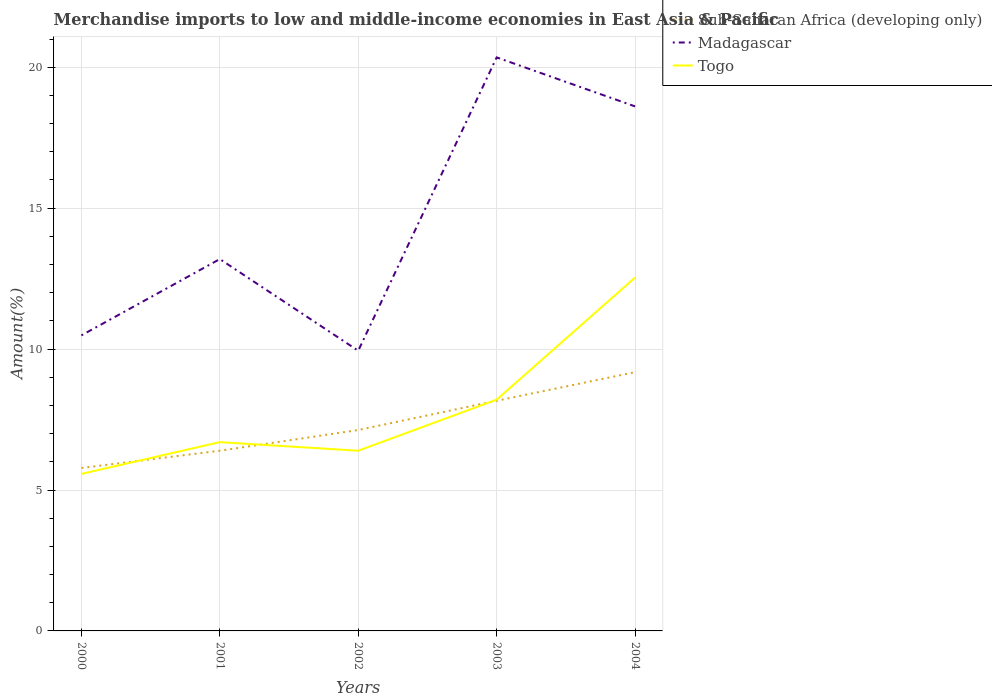Across all years, what is the maximum percentage of amount earned from merchandise imports in Sub-Saharan Africa (developing only)?
Keep it short and to the point. 5.78. What is the total percentage of amount earned from merchandise imports in Sub-Saharan Africa (developing only) in the graph?
Provide a succinct answer. -1.01. What is the difference between the highest and the second highest percentage of amount earned from merchandise imports in Madagascar?
Offer a terse response. 10.41. Is the percentage of amount earned from merchandise imports in Sub-Saharan Africa (developing only) strictly greater than the percentage of amount earned from merchandise imports in Togo over the years?
Ensure brevity in your answer.  No. How many years are there in the graph?
Keep it short and to the point. 5. Does the graph contain grids?
Ensure brevity in your answer.  Yes. How many legend labels are there?
Provide a short and direct response. 3. How are the legend labels stacked?
Your answer should be very brief. Vertical. What is the title of the graph?
Give a very brief answer. Merchandise imports to low and middle-income economies in East Asia & Pacific. Does "St. Martin (French part)" appear as one of the legend labels in the graph?
Your answer should be very brief. No. What is the label or title of the X-axis?
Provide a succinct answer. Years. What is the label or title of the Y-axis?
Ensure brevity in your answer.  Amount(%). What is the Amount(%) in Sub-Saharan Africa (developing only) in 2000?
Offer a very short reply. 5.78. What is the Amount(%) in Madagascar in 2000?
Make the answer very short. 10.49. What is the Amount(%) in Togo in 2000?
Provide a short and direct response. 5.57. What is the Amount(%) of Sub-Saharan Africa (developing only) in 2001?
Give a very brief answer. 6.39. What is the Amount(%) in Madagascar in 2001?
Ensure brevity in your answer.  13.19. What is the Amount(%) of Togo in 2001?
Make the answer very short. 6.7. What is the Amount(%) in Sub-Saharan Africa (developing only) in 2002?
Your answer should be very brief. 7.13. What is the Amount(%) in Madagascar in 2002?
Provide a succinct answer. 9.94. What is the Amount(%) of Togo in 2002?
Offer a terse response. 6.39. What is the Amount(%) in Sub-Saharan Africa (developing only) in 2003?
Provide a succinct answer. 8.17. What is the Amount(%) of Madagascar in 2003?
Ensure brevity in your answer.  20.35. What is the Amount(%) of Togo in 2003?
Offer a very short reply. 8.21. What is the Amount(%) of Sub-Saharan Africa (developing only) in 2004?
Offer a very short reply. 9.18. What is the Amount(%) of Madagascar in 2004?
Offer a terse response. 18.61. What is the Amount(%) of Togo in 2004?
Provide a short and direct response. 12.54. Across all years, what is the maximum Amount(%) in Sub-Saharan Africa (developing only)?
Your response must be concise. 9.18. Across all years, what is the maximum Amount(%) of Madagascar?
Ensure brevity in your answer.  20.35. Across all years, what is the maximum Amount(%) in Togo?
Ensure brevity in your answer.  12.54. Across all years, what is the minimum Amount(%) in Sub-Saharan Africa (developing only)?
Your answer should be compact. 5.78. Across all years, what is the minimum Amount(%) of Madagascar?
Give a very brief answer. 9.94. Across all years, what is the minimum Amount(%) in Togo?
Provide a short and direct response. 5.57. What is the total Amount(%) of Sub-Saharan Africa (developing only) in the graph?
Your answer should be very brief. 36.65. What is the total Amount(%) in Madagascar in the graph?
Offer a terse response. 72.58. What is the total Amount(%) in Togo in the graph?
Offer a terse response. 39.41. What is the difference between the Amount(%) of Sub-Saharan Africa (developing only) in 2000 and that in 2001?
Provide a short and direct response. -0.61. What is the difference between the Amount(%) in Madagascar in 2000 and that in 2001?
Your answer should be compact. -2.71. What is the difference between the Amount(%) in Togo in 2000 and that in 2001?
Your response must be concise. -1.13. What is the difference between the Amount(%) in Sub-Saharan Africa (developing only) in 2000 and that in 2002?
Ensure brevity in your answer.  -1.35. What is the difference between the Amount(%) of Madagascar in 2000 and that in 2002?
Your answer should be very brief. 0.54. What is the difference between the Amount(%) of Togo in 2000 and that in 2002?
Provide a succinct answer. -0.82. What is the difference between the Amount(%) of Sub-Saharan Africa (developing only) in 2000 and that in 2003?
Provide a short and direct response. -2.39. What is the difference between the Amount(%) in Madagascar in 2000 and that in 2003?
Provide a succinct answer. -9.86. What is the difference between the Amount(%) in Togo in 2000 and that in 2003?
Offer a very short reply. -2.64. What is the difference between the Amount(%) in Sub-Saharan Africa (developing only) in 2000 and that in 2004?
Your answer should be compact. -3.4. What is the difference between the Amount(%) in Madagascar in 2000 and that in 2004?
Your answer should be very brief. -8.12. What is the difference between the Amount(%) in Togo in 2000 and that in 2004?
Offer a very short reply. -6.97. What is the difference between the Amount(%) in Sub-Saharan Africa (developing only) in 2001 and that in 2002?
Offer a terse response. -0.74. What is the difference between the Amount(%) of Madagascar in 2001 and that in 2002?
Give a very brief answer. 3.25. What is the difference between the Amount(%) of Togo in 2001 and that in 2002?
Your answer should be compact. 0.3. What is the difference between the Amount(%) of Sub-Saharan Africa (developing only) in 2001 and that in 2003?
Provide a short and direct response. -1.77. What is the difference between the Amount(%) of Madagascar in 2001 and that in 2003?
Make the answer very short. -7.16. What is the difference between the Amount(%) in Togo in 2001 and that in 2003?
Offer a very short reply. -1.51. What is the difference between the Amount(%) in Sub-Saharan Africa (developing only) in 2001 and that in 2004?
Your answer should be very brief. -2.79. What is the difference between the Amount(%) of Madagascar in 2001 and that in 2004?
Give a very brief answer. -5.42. What is the difference between the Amount(%) in Togo in 2001 and that in 2004?
Your response must be concise. -5.84. What is the difference between the Amount(%) in Sub-Saharan Africa (developing only) in 2002 and that in 2003?
Your answer should be compact. -1.04. What is the difference between the Amount(%) in Madagascar in 2002 and that in 2003?
Give a very brief answer. -10.41. What is the difference between the Amount(%) in Togo in 2002 and that in 2003?
Keep it short and to the point. -1.81. What is the difference between the Amount(%) in Sub-Saharan Africa (developing only) in 2002 and that in 2004?
Make the answer very short. -2.05. What is the difference between the Amount(%) of Madagascar in 2002 and that in 2004?
Offer a terse response. -8.67. What is the difference between the Amount(%) in Togo in 2002 and that in 2004?
Keep it short and to the point. -6.15. What is the difference between the Amount(%) in Sub-Saharan Africa (developing only) in 2003 and that in 2004?
Provide a succinct answer. -1.01. What is the difference between the Amount(%) of Madagascar in 2003 and that in 2004?
Your response must be concise. 1.74. What is the difference between the Amount(%) of Togo in 2003 and that in 2004?
Keep it short and to the point. -4.33. What is the difference between the Amount(%) of Sub-Saharan Africa (developing only) in 2000 and the Amount(%) of Madagascar in 2001?
Provide a short and direct response. -7.41. What is the difference between the Amount(%) of Sub-Saharan Africa (developing only) in 2000 and the Amount(%) of Togo in 2001?
Provide a succinct answer. -0.92. What is the difference between the Amount(%) of Madagascar in 2000 and the Amount(%) of Togo in 2001?
Your answer should be compact. 3.79. What is the difference between the Amount(%) of Sub-Saharan Africa (developing only) in 2000 and the Amount(%) of Madagascar in 2002?
Keep it short and to the point. -4.16. What is the difference between the Amount(%) in Sub-Saharan Africa (developing only) in 2000 and the Amount(%) in Togo in 2002?
Ensure brevity in your answer.  -0.61. What is the difference between the Amount(%) of Madagascar in 2000 and the Amount(%) of Togo in 2002?
Offer a terse response. 4.09. What is the difference between the Amount(%) of Sub-Saharan Africa (developing only) in 2000 and the Amount(%) of Madagascar in 2003?
Offer a terse response. -14.57. What is the difference between the Amount(%) of Sub-Saharan Africa (developing only) in 2000 and the Amount(%) of Togo in 2003?
Keep it short and to the point. -2.42. What is the difference between the Amount(%) in Madagascar in 2000 and the Amount(%) in Togo in 2003?
Ensure brevity in your answer.  2.28. What is the difference between the Amount(%) of Sub-Saharan Africa (developing only) in 2000 and the Amount(%) of Madagascar in 2004?
Provide a short and direct response. -12.83. What is the difference between the Amount(%) in Sub-Saharan Africa (developing only) in 2000 and the Amount(%) in Togo in 2004?
Your answer should be very brief. -6.76. What is the difference between the Amount(%) in Madagascar in 2000 and the Amount(%) in Togo in 2004?
Make the answer very short. -2.05. What is the difference between the Amount(%) of Sub-Saharan Africa (developing only) in 2001 and the Amount(%) of Madagascar in 2002?
Make the answer very short. -3.55. What is the difference between the Amount(%) of Madagascar in 2001 and the Amount(%) of Togo in 2002?
Ensure brevity in your answer.  6.8. What is the difference between the Amount(%) of Sub-Saharan Africa (developing only) in 2001 and the Amount(%) of Madagascar in 2003?
Offer a very short reply. -13.96. What is the difference between the Amount(%) in Sub-Saharan Africa (developing only) in 2001 and the Amount(%) in Togo in 2003?
Offer a terse response. -1.81. What is the difference between the Amount(%) in Madagascar in 2001 and the Amount(%) in Togo in 2003?
Your response must be concise. 4.99. What is the difference between the Amount(%) in Sub-Saharan Africa (developing only) in 2001 and the Amount(%) in Madagascar in 2004?
Provide a succinct answer. -12.22. What is the difference between the Amount(%) in Sub-Saharan Africa (developing only) in 2001 and the Amount(%) in Togo in 2004?
Make the answer very short. -6.15. What is the difference between the Amount(%) of Madagascar in 2001 and the Amount(%) of Togo in 2004?
Offer a very short reply. 0.65. What is the difference between the Amount(%) of Sub-Saharan Africa (developing only) in 2002 and the Amount(%) of Madagascar in 2003?
Offer a very short reply. -13.22. What is the difference between the Amount(%) of Sub-Saharan Africa (developing only) in 2002 and the Amount(%) of Togo in 2003?
Give a very brief answer. -1.08. What is the difference between the Amount(%) of Madagascar in 2002 and the Amount(%) of Togo in 2003?
Provide a succinct answer. 1.74. What is the difference between the Amount(%) of Sub-Saharan Africa (developing only) in 2002 and the Amount(%) of Madagascar in 2004?
Offer a terse response. -11.48. What is the difference between the Amount(%) in Sub-Saharan Africa (developing only) in 2002 and the Amount(%) in Togo in 2004?
Provide a succinct answer. -5.41. What is the difference between the Amount(%) in Madagascar in 2002 and the Amount(%) in Togo in 2004?
Make the answer very short. -2.6. What is the difference between the Amount(%) of Sub-Saharan Africa (developing only) in 2003 and the Amount(%) of Madagascar in 2004?
Your answer should be very brief. -10.44. What is the difference between the Amount(%) in Sub-Saharan Africa (developing only) in 2003 and the Amount(%) in Togo in 2004?
Make the answer very short. -4.37. What is the difference between the Amount(%) of Madagascar in 2003 and the Amount(%) of Togo in 2004?
Offer a very short reply. 7.81. What is the average Amount(%) in Sub-Saharan Africa (developing only) per year?
Ensure brevity in your answer.  7.33. What is the average Amount(%) of Madagascar per year?
Give a very brief answer. 14.52. What is the average Amount(%) of Togo per year?
Your answer should be compact. 7.88. In the year 2000, what is the difference between the Amount(%) of Sub-Saharan Africa (developing only) and Amount(%) of Madagascar?
Keep it short and to the point. -4.71. In the year 2000, what is the difference between the Amount(%) of Sub-Saharan Africa (developing only) and Amount(%) of Togo?
Provide a succinct answer. 0.21. In the year 2000, what is the difference between the Amount(%) in Madagascar and Amount(%) in Togo?
Provide a short and direct response. 4.92. In the year 2001, what is the difference between the Amount(%) of Sub-Saharan Africa (developing only) and Amount(%) of Madagascar?
Your answer should be very brief. -6.8. In the year 2001, what is the difference between the Amount(%) in Sub-Saharan Africa (developing only) and Amount(%) in Togo?
Your answer should be compact. -0.3. In the year 2001, what is the difference between the Amount(%) in Madagascar and Amount(%) in Togo?
Your answer should be very brief. 6.5. In the year 2002, what is the difference between the Amount(%) in Sub-Saharan Africa (developing only) and Amount(%) in Madagascar?
Offer a very short reply. -2.81. In the year 2002, what is the difference between the Amount(%) of Sub-Saharan Africa (developing only) and Amount(%) of Togo?
Your answer should be compact. 0.74. In the year 2002, what is the difference between the Amount(%) in Madagascar and Amount(%) in Togo?
Keep it short and to the point. 3.55. In the year 2003, what is the difference between the Amount(%) in Sub-Saharan Africa (developing only) and Amount(%) in Madagascar?
Your answer should be very brief. -12.18. In the year 2003, what is the difference between the Amount(%) in Sub-Saharan Africa (developing only) and Amount(%) in Togo?
Keep it short and to the point. -0.04. In the year 2003, what is the difference between the Amount(%) in Madagascar and Amount(%) in Togo?
Provide a short and direct response. 12.14. In the year 2004, what is the difference between the Amount(%) in Sub-Saharan Africa (developing only) and Amount(%) in Madagascar?
Make the answer very short. -9.43. In the year 2004, what is the difference between the Amount(%) of Sub-Saharan Africa (developing only) and Amount(%) of Togo?
Your answer should be very brief. -3.36. In the year 2004, what is the difference between the Amount(%) in Madagascar and Amount(%) in Togo?
Give a very brief answer. 6.07. What is the ratio of the Amount(%) of Sub-Saharan Africa (developing only) in 2000 to that in 2001?
Ensure brevity in your answer.  0.9. What is the ratio of the Amount(%) in Madagascar in 2000 to that in 2001?
Give a very brief answer. 0.79. What is the ratio of the Amount(%) of Togo in 2000 to that in 2001?
Offer a very short reply. 0.83. What is the ratio of the Amount(%) in Sub-Saharan Africa (developing only) in 2000 to that in 2002?
Give a very brief answer. 0.81. What is the ratio of the Amount(%) in Madagascar in 2000 to that in 2002?
Offer a terse response. 1.05. What is the ratio of the Amount(%) of Togo in 2000 to that in 2002?
Ensure brevity in your answer.  0.87. What is the ratio of the Amount(%) in Sub-Saharan Africa (developing only) in 2000 to that in 2003?
Offer a terse response. 0.71. What is the ratio of the Amount(%) of Madagascar in 2000 to that in 2003?
Provide a succinct answer. 0.52. What is the ratio of the Amount(%) in Togo in 2000 to that in 2003?
Give a very brief answer. 0.68. What is the ratio of the Amount(%) of Sub-Saharan Africa (developing only) in 2000 to that in 2004?
Give a very brief answer. 0.63. What is the ratio of the Amount(%) of Madagascar in 2000 to that in 2004?
Your answer should be compact. 0.56. What is the ratio of the Amount(%) in Togo in 2000 to that in 2004?
Provide a short and direct response. 0.44. What is the ratio of the Amount(%) of Sub-Saharan Africa (developing only) in 2001 to that in 2002?
Keep it short and to the point. 0.9. What is the ratio of the Amount(%) of Madagascar in 2001 to that in 2002?
Provide a succinct answer. 1.33. What is the ratio of the Amount(%) of Togo in 2001 to that in 2002?
Your response must be concise. 1.05. What is the ratio of the Amount(%) in Sub-Saharan Africa (developing only) in 2001 to that in 2003?
Ensure brevity in your answer.  0.78. What is the ratio of the Amount(%) of Madagascar in 2001 to that in 2003?
Make the answer very short. 0.65. What is the ratio of the Amount(%) in Togo in 2001 to that in 2003?
Offer a terse response. 0.82. What is the ratio of the Amount(%) of Sub-Saharan Africa (developing only) in 2001 to that in 2004?
Ensure brevity in your answer.  0.7. What is the ratio of the Amount(%) in Madagascar in 2001 to that in 2004?
Provide a succinct answer. 0.71. What is the ratio of the Amount(%) of Togo in 2001 to that in 2004?
Provide a succinct answer. 0.53. What is the ratio of the Amount(%) of Sub-Saharan Africa (developing only) in 2002 to that in 2003?
Keep it short and to the point. 0.87. What is the ratio of the Amount(%) in Madagascar in 2002 to that in 2003?
Your answer should be very brief. 0.49. What is the ratio of the Amount(%) in Togo in 2002 to that in 2003?
Offer a terse response. 0.78. What is the ratio of the Amount(%) of Sub-Saharan Africa (developing only) in 2002 to that in 2004?
Give a very brief answer. 0.78. What is the ratio of the Amount(%) in Madagascar in 2002 to that in 2004?
Ensure brevity in your answer.  0.53. What is the ratio of the Amount(%) in Togo in 2002 to that in 2004?
Your answer should be very brief. 0.51. What is the ratio of the Amount(%) of Sub-Saharan Africa (developing only) in 2003 to that in 2004?
Keep it short and to the point. 0.89. What is the ratio of the Amount(%) in Madagascar in 2003 to that in 2004?
Provide a short and direct response. 1.09. What is the ratio of the Amount(%) in Togo in 2003 to that in 2004?
Your answer should be very brief. 0.65. What is the difference between the highest and the second highest Amount(%) in Sub-Saharan Africa (developing only)?
Keep it short and to the point. 1.01. What is the difference between the highest and the second highest Amount(%) of Madagascar?
Offer a terse response. 1.74. What is the difference between the highest and the second highest Amount(%) of Togo?
Give a very brief answer. 4.33. What is the difference between the highest and the lowest Amount(%) of Sub-Saharan Africa (developing only)?
Give a very brief answer. 3.4. What is the difference between the highest and the lowest Amount(%) in Madagascar?
Offer a very short reply. 10.41. What is the difference between the highest and the lowest Amount(%) of Togo?
Your answer should be compact. 6.97. 